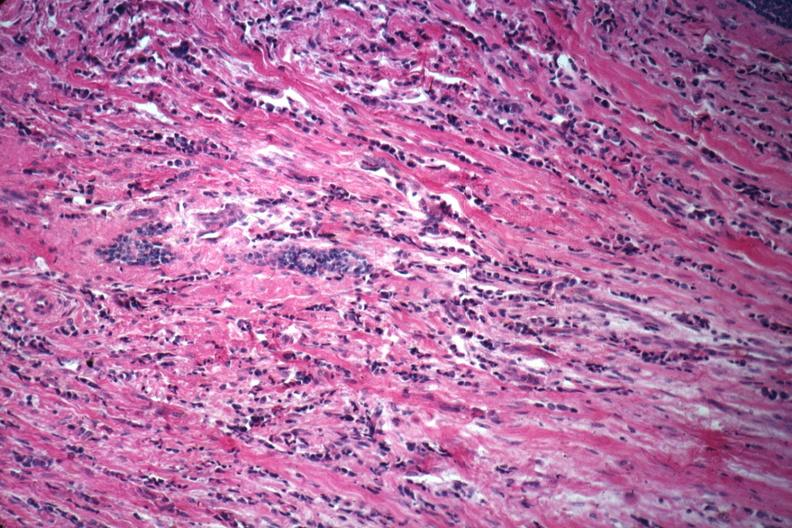where is this area in the body?
Answer the question using a single word or phrase. Breast 